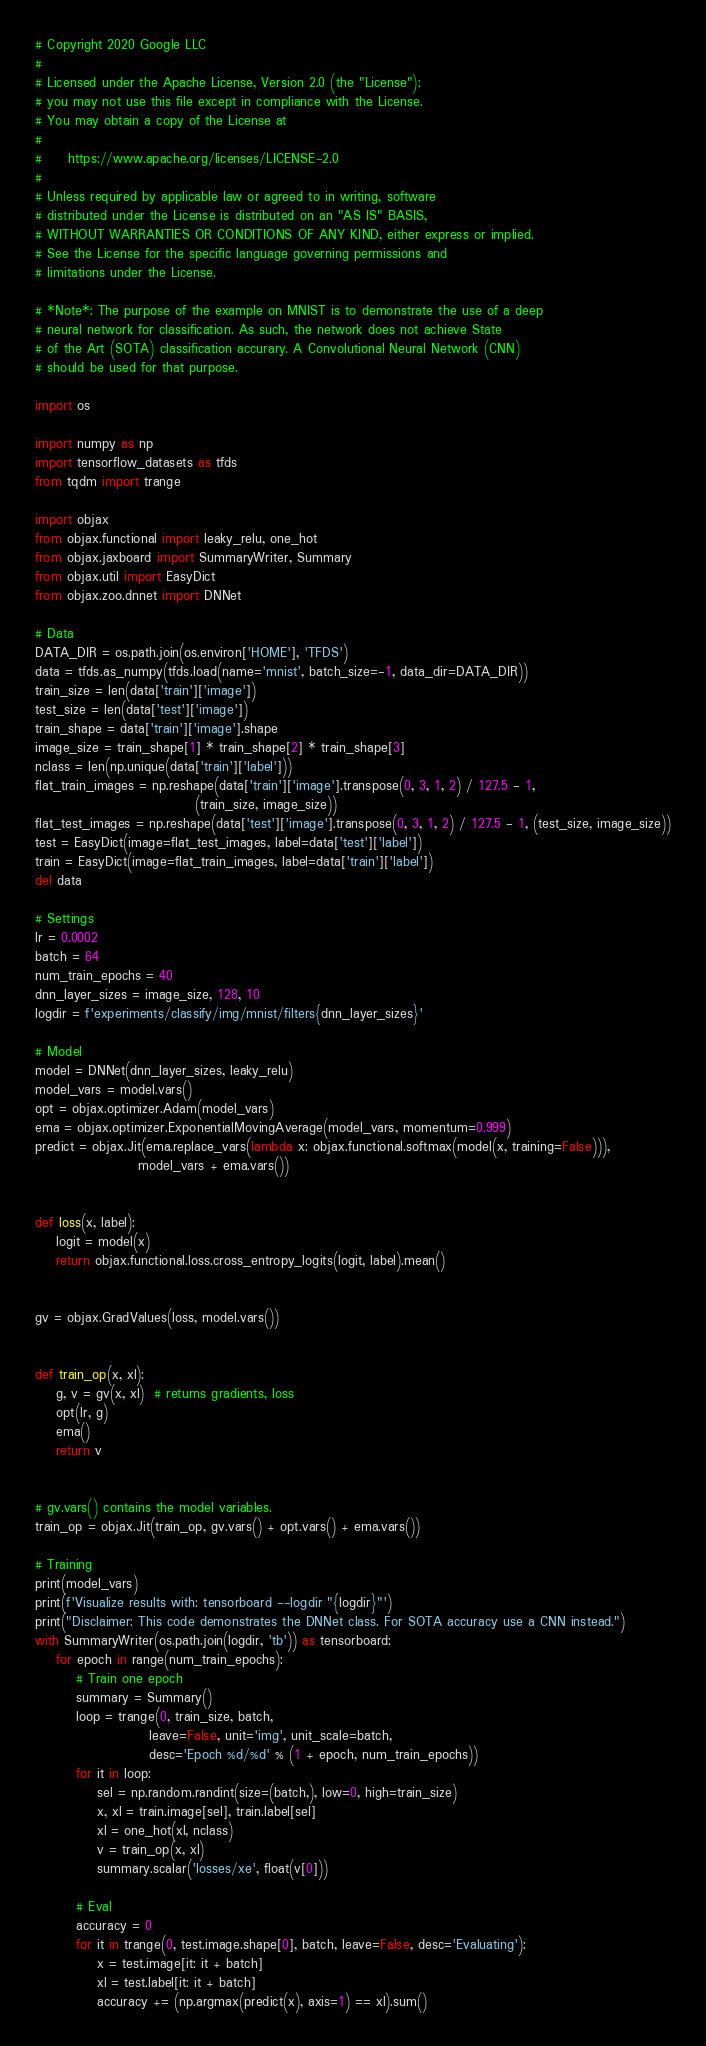Convert code to text. <code><loc_0><loc_0><loc_500><loc_500><_Python_># Copyright 2020 Google LLC
#
# Licensed under the Apache License, Version 2.0 (the "License");
# you may not use this file except in compliance with the License.
# You may obtain a copy of the License at
#
#     https://www.apache.org/licenses/LICENSE-2.0
#
# Unless required by applicable law or agreed to in writing, software
# distributed under the License is distributed on an "AS IS" BASIS,
# WITHOUT WARRANTIES OR CONDITIONS OF ANY KIND, either express or implied.
# See the License for the specific language governing permissions and
# limitations under the License.

# *Note*: The purpose of the example on MNIST is to demonstrate the use of a deep
# neural network for classification. As such, the network does not achieve State
# of the Art (SOTA) classification accurary. A Convolutional Neural Network (CNN)
# should be used for that purpose.

import os

import numpy as np
import tensorflow_datasets as tfds
from tqdm import trange

import objax
from objax.functional import leaky_relu, one_hot
from objax.jaxboard import SummaryWriter, Summary
from objax.util import EasyDict
from objax.zoo.dnnet import DNNet

# Data
DATA_DIR = os.path.join(os.environ['HOME'], 'TFDS')
data = tfds.as_numpy(tfds.load(name='mnist', batch_size=-1, data_dir=DATA_DIR))
train_size = len(data['train']['image'])
test_size = len(data['test']['image'])
train_shape = data['train']['image'].shape
image_size = train_shape[1] * train_shape[2] * train_shape[3]
nclass = len(np.unique(data['train']['label']))
flat_train_images = np.reshape(data['train']['image'].transpose(0, 3, 1, 2) / 127.5 - 1,
                               (train_size, image_size))
flat_test_images = np.reshape(data['test']['image'].transpose(0, 3, 1, 2) / 127.5 - 1, (test_size, image_size))
test = EasyDict(image=flat_test_images, label=data['test']['label'])
train = EasyDict(image=flat_train_images, label=data['train']['label'])
del data

# Settings
lr = 0.0002
batch = 64
num_train_epochs = 40
dnn_layer_sizes = image_size, 128, 10
logdir = f'experiments/classify/img/mnist/filters{dnn_layer_sizes}'

# Model
model = DNNet(dnn_layer_sizes, leaky_relu)
model_vars = model.vars()
opt = objax.optimizer.Adam(model_vars)
ema = objax.optimizer.ExponentialMovingAverage(model_vars, momentum=0.999)
predict = objax.Jit(ema.replace_vars(lambda x: objax.functional.softmax(model(x, training=False))),
                    model_vars + ema.vars())


def loss(x, label):
    logit = model(x)
    return objax.functional.loss.cross_entropy_logits(logit, label).mean()


gv = objax.GradValues(loss, model.vars())


def train_op(x, xl):
    g, v = gv(x, xl)  # returns gradients, loss
    opt(lr, g)
    ema()
    return v


# gv.vars() contains the model variables.
train_op = objax.Jit(train_op, gv.vars() + opt.vars() + ema.vars())

# Training
print(model_vars)
print(f'Visualize results with: tensorboard --logdir "{logdir}"')
print("Disclaimer: This code demonstrates the DNNet class. For SOTA accuracy use a CNN instead.")
with SummaryWriter(os.path.join(logdir, 'tb')) as tensorboard:
    for epoch in range(num_train_epochs):
        # Train one epoch
        summary = Summary()
        loop = trange(0, train_size, batch,
                      leave=False, unit='img', unit_scale=batch,
                      desc='Epoch %d/%d' % (1 + epoch, num_train_epochs))
        for it in loop:
            sel = np.random.randint(size=(batch,), low=0, high=train_size)
            x, xl = train.image[sel], train.label[sel]
            xl = one_hot(xl, nclass)
            v = train_op(x, xl)
            summary.scalar('losses/xe', float(v[0]))

        # Eval
        accuracy = 0
        for it in trange(0, test.image.shape[0], batch, leave=False, desc='Evaluating'):
            x = test.image[it: it + batch]
            xl = test.label[it: it + batch]
            accuracy += (np.argmax(predict(x), axis=1) == xl).sum()</code> 